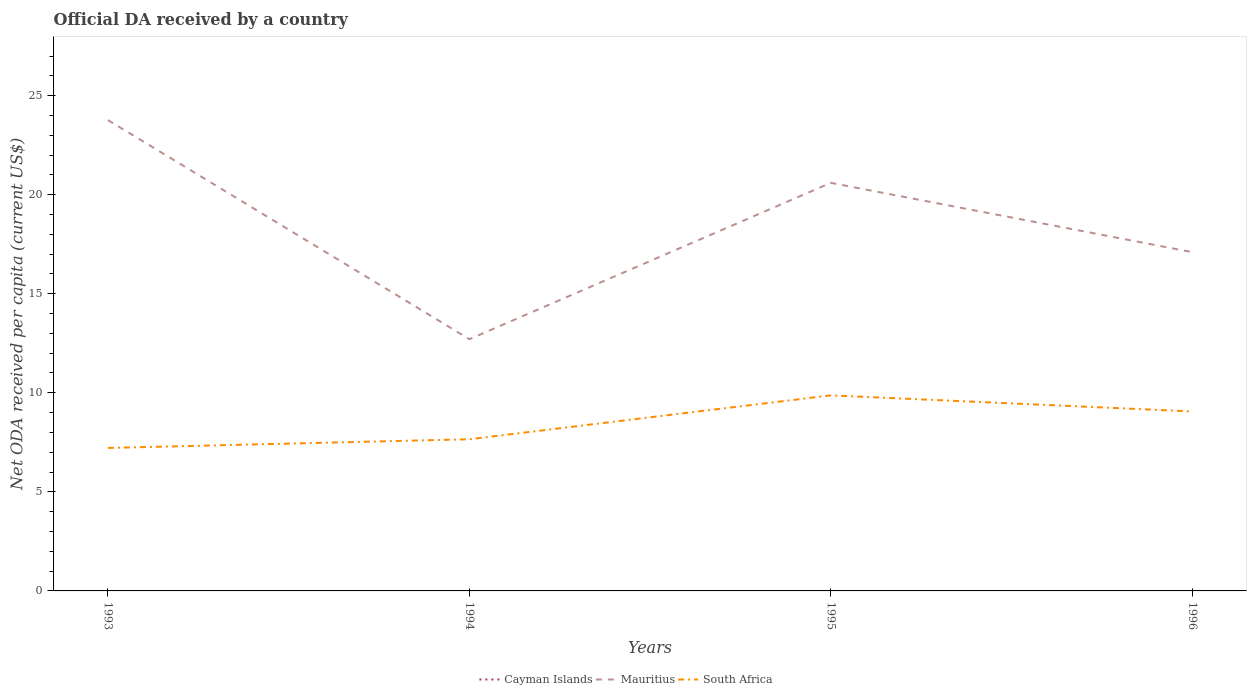Is the number of lines equal to the number of legend labels?
Ensure brevity in your answer.  No. What is the total ODA received in in South Africa in the graph?
Your answer should be very brief. -1.4. What is the difference between the highest and the second highest ODA received in in South Africa?
Offer a very short reply. 2.65. What is the difference between the highest and the lowest ODA received in in South Africa?
Make the answer very short. 2. Is the ODA received in in Mauritius strictly greater than the ODA received in in South Africa over the years?
Keep it short and to the point. No. Are the values on the major ticks of Y-axis written in scientific E-notation?
Provide a short and direct response. No. Does the graph contain any zero values?
Keep it short and to the point. Yes. Does the graph contain grids?
Offer a terse response. No. What is the title of the graph?
Your answer should be very brief. Official DA received by a country. What is the label or title of the X-axis?
Make the answer very short. Years. What is the label or title of the Y-axis?
Your answer should be very brief. Net ODA received per capita (current US$). What is the Net ODA received per capita (current US$) in Cayman Islands in 1993?
Offer a terse response. 0. What is the Net ODA received per capita (current US$) of Mauritius in 1993?
Your answer should be compact. 23.77. What is the Net ODA received per capita (current US$) of South Africa in 1993?
Your answer should be compact. 7.22. What is the Net ODA received per capita (current US$) in Mauritius in 1994?
Offer a terse response. 12.71. What is the Net ODA received per capita (current US$) of South Africa in 1994?
Ensure brevity in your answer.  7.66. What is the Net ODA received per capita (current US$) of Mauritius in 1995?
Offer a very short reply. 20.6. What is the Net ODA received per capita (current US$) in South Africa in 1995?
Offer a very short reply. 9.87. What is the Net ODA received per capita (current US$) in Cayman Islands in 1996?
Offer a terse response. 0. What is the Net ODA received per capita (current US$) of Mauritius in 1996?
Keep it short and to the point. 17.1. What is the Net ODA received per capita (current US$) of South Africa in 1996?
Offer a terse response. 9.06. Across all years, what is the maximum Net ODA received per capita (current US$) of Mauritius?
Provide a short and direct response. 23.77. Across all years, what is the maximum Net ODA received per capita (current US$) in South Africa?
Your answer should be very brief. 9.87. Across all years, what is the minimum Net ODA received per capita (current US$) in Mauritius?
Your response must be concise. 12.71. Across all years, what is the minimum Net ODA received per capita (current US$) of South Africa?
Provide a succinct answer. 7.22. What is the total Net ODA received per capita (current US$) in Cayman Islands in the graph?
Ensure brevity in your answer.  0. What is the total Net ODA received per capita (current US$) in Mauritius in the graph?
Offer a very short reply. 74.17. What is the total Net ODA received per capita (current US$) of South Africa in the graph?
Your answer should be compact. 33.8. What is the difference between the Net ODA received per capita (current US$) of Mauritius in 1993 and that in 1994?
Your answer should be very brief. 11.06. What is the difference between the Net ODA received per capita (current US$) in South Africa in 1993 and that in 1994?
Keep it short and to the point. -0.44. What is the difference between the Net ODA received per capita (current US$) of Mauritius in 1993 and that in 1995?
Make the answer very short. 3.17. What is the difference between the Net ODA received per capita (current US$) of South Africa in 1993 and that in 1995?
Keep it short and to the point. -2.65. What is the difference between the Net ODA received per capita (current US$) of Mauritius in 1993 and that in 1996?
Give a very brief answer. 6.67. What is the difference between the Net ODA received per capita (current US$) of South Africa in 1993 and that in 1996?
Your answer should be compact. -1.84. What is the difference between the Net ODA received per capita (current US$) of Mauritius in 1994 and that in 1995?
Offer a terse response. -7.89. What is the difference between the Net ODA received per capita (current US$) of South Africa in 1994 and that in 1995?
Your answer should be very brief. -2.22. What is the difference between the Net ODA received per capita (current US$) in Mauritius in 1994 and that in 1996?
Your response must be concise. -4.39. What is the difference between the Net ODA received per capita (current US$) of South Africa in 1994 and that in 1996?
Offer a very short reply. -1.4. What is the difference between the Net ODA received per capita (current US$) in Mauritius in 1995 and that in 1996?
Ensure brevity in your answer.  3.5. What is the difference between the Net ODA received per capita (current US$) in South Africa in 1995 and that in 1996?
Your answer should be compact. 0.81. What is the difference between the Net ODA received per capita (current US$) of Mauritius in 1993 and the Net ODA received per capita (current US$) of South Africa in 1994?
Provide a short and direct response. 16.11. What is the difference between the Net ODA received per capita (current US$) of Mauritius in 1993 and the Net ODA received per capita (current US$) of South Africa in 1995?
Your response must be concise. 13.89. What is the difference between the Net ODA received per capita (current US$) in Mauritius in 1993 and the Net ODA received per capita (current US$) in South Africa in 1996?
Your answer should be very brief. 14.71. What is the difference between the Net ODA received per capita (current US$) in Mauritius in 1994 and the Net ODA received per capita (current US$) in South Africa in 1995?
Your answer should be compact. 2.83. What is the difference between the Net ODA received per capita (current US$) in Mauritius in 1994 and the Net ODA received per capita (current US$) in South Africa in 1996?
Give a very brief answer. 3.65. What is the difference between the Net ODA received per capita (current US$) of Mauritius in 1995 and the Net ODA received per capita (current US$) of South Africa in 1996?
Make the answer very short. 11.54. What is the average Net ODA received per capita (current US$) of Cayman Islands per year?
Offer a terse response. 0. What is the average Net ODA received per capita (current US$) of Mauritius per year?
Keep it short and to the point. 18.54. What is the average Net ODA received per capita (current US$) in South Africa per year?
Your answer should be compact. 8.45. In the year 1993, what is the difference between the Net ODA received per capita (current US$) of Mauritius and Net ODA received per capita (current US$) of South Africa?
Your answer should be very brief. 16.55. In the year 1994, what is the difference between the Net ODA received per capita (current US$) in Mauritius and Net ODA received per capita (current US$) in South Africa?
Provide a succinct answer. 5.05. In the year 1995, what is the difference between the Net ODA received per capita (current US$) in Mauritius and Net ODA received per capita (current US$) in South Africa?
Provide a succinct answer. 10.73. In the year 1996, what is the difference between the Net ODA received per capita (current US$) in Mauritius and Net ODA received per capita (current US$) in South Africa?
Your answer should be compact. 8.04. What is the ratio of the Net ODA received per capita (current US$) in Mauritius in 1993 to that in 1994?
Offer a very short reply. 1.87. What is the ratio of the Net ODA received per capita (current US$) in South Africa in 1993 to that in 1994?
Offer a very short reply. 0.94. What is the ratio of the Net ODA received per capita (current US$) of Mauritius in 1993 to that in 1995?
Keep it short and to the point. 1.15. What is the ratio of the Net ODA received per capita (current US$) of South Africa in 1993 to that in 1995?
Provide a succinct answer. 0.73. What is the ratio of the Net ODA received per capita (current US$) in Mauritius in 1993 to that in 1996?
Your answer should be compact. 1.39. What is the ratio of the Net ODA received per capita (current US$) of South Africa in 1993 to that in 1996?
Keep it short and to the point. 0.8. What is the ratio of the Net ODA received per capita (current US$) in Mauritius in 1994 to that in 1995?
Keep it short and to the point. 0.62. What is the ratio of the Net ODA received per capita (current US$) of South Africa in 1994 to that in 1995?
Your answer should be very brief. 0.78. What is the ratio of the Net ODA received per capita (current US$) in Mauritius in 1994 to that in 1996?
Your answer should be compact. 0.74. What is the ratio of the Net ODA received per capita (current US$) in South Africa in 1994 to that in 1996?
Your answer should be very brief. 0.85. What is the ratio of the Net ODA received per capita (current US$) in Mauritius in 1995 to that in 1996?
Your response must be concise. 1.2. What is the ratio of the Net ODA received per capita (current US$) of South Africa in 1995 to that in 1996?
Your answer should be very brief. 1.09. What is the difference between the highest and the second highest Net ODA received per capita (current US$) of Mauritius?
Your answer should be compact. 3.17. What is the difference between the highest and the second highest Net ODA received per capita (current US$) of South Africa?
Provide a succinct answer. 0.81. What is the difference between the highest and the lowest Net ODA received per capita (current US$) of Mauritius?
Your answer should be very brief. 11.06. What is the difference between the highest and the lowest Net ODA received per capita (current US$) of South Africa?
Offer a terse response. 2.65. 